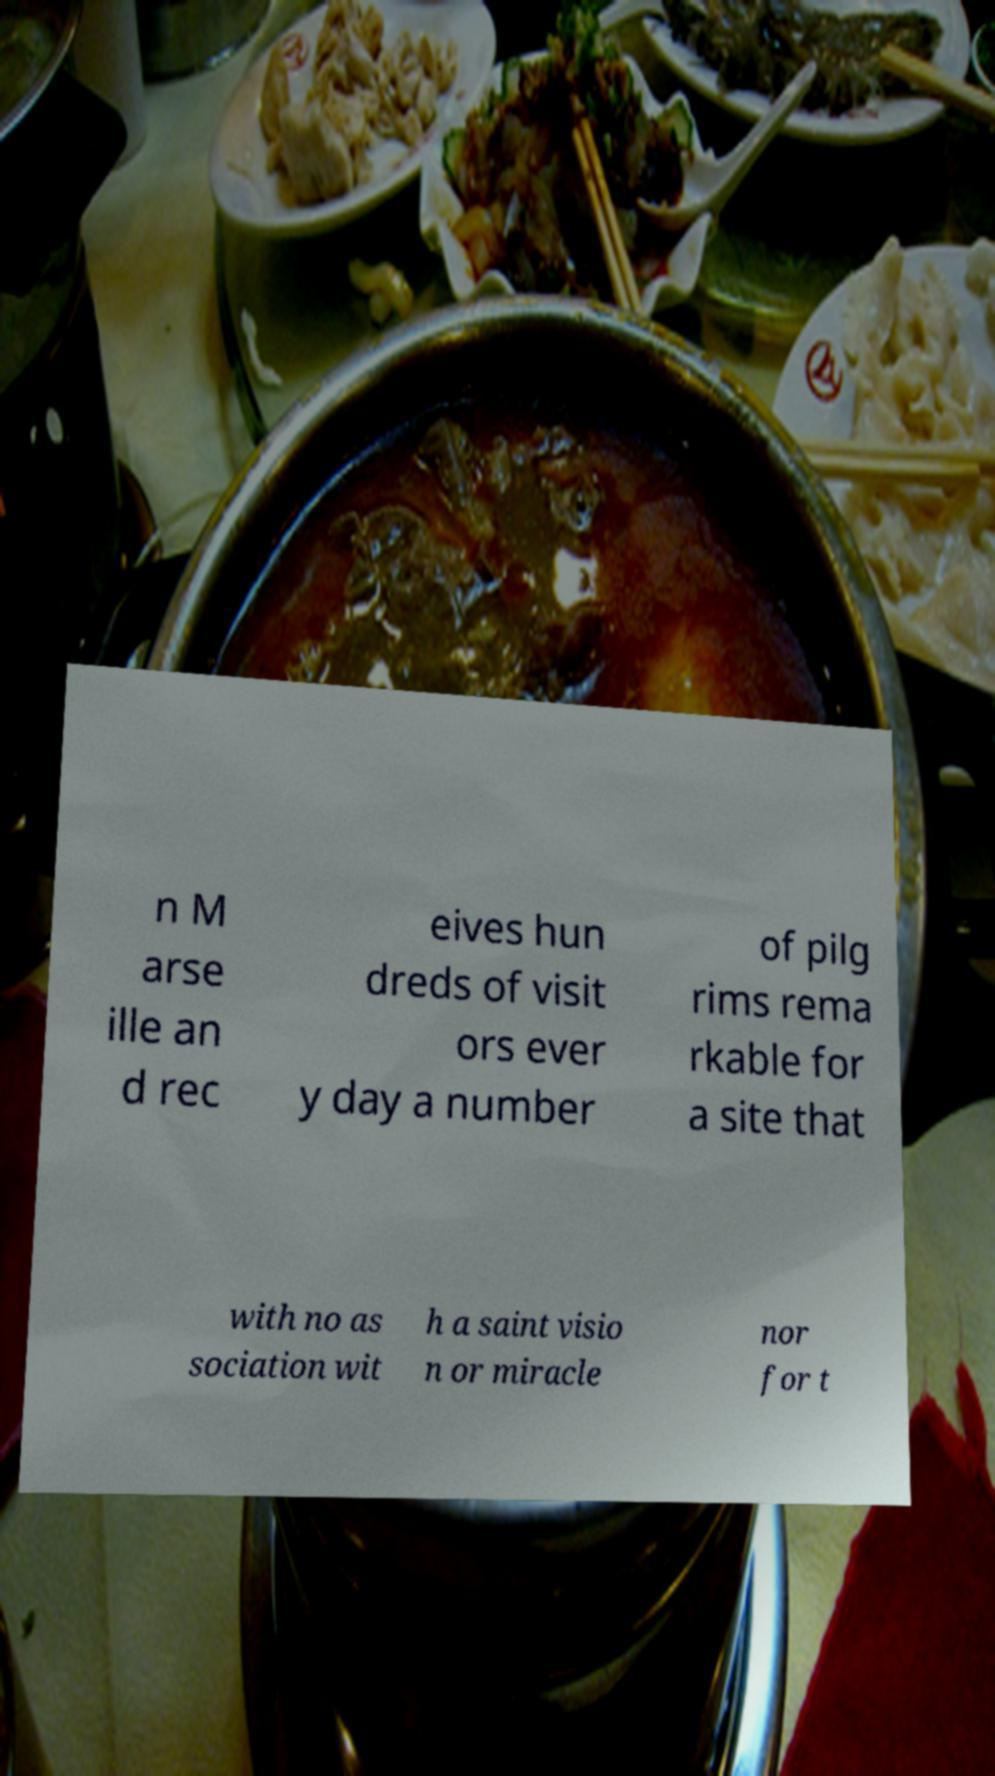For documentation purposes, I need the text within this image transcribed. Could you provide that? n M arse ille an d rec eives hun dreds of visit ors ever y day a number of pilg rims rema rkable for a site that with no as sociation wit h a saint visio n or miracle nor for t 